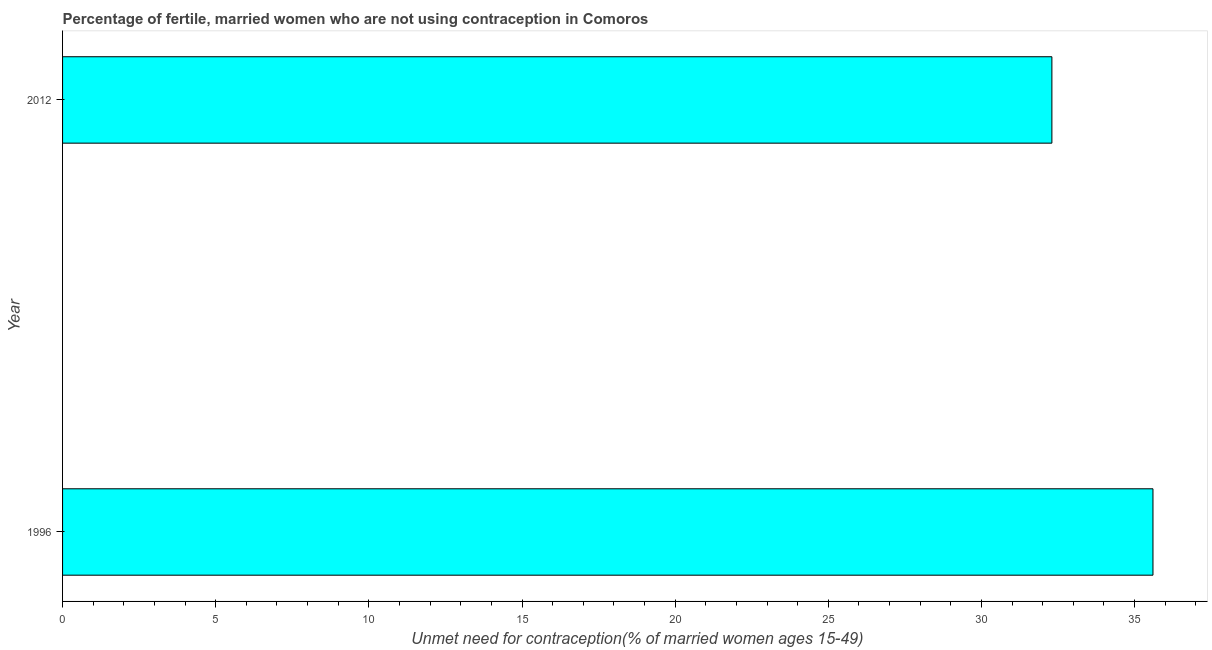Does the graph contain any zero values?
Your answer should be compact. No. What is the title of the graph?
Your answer should be compact. Percentage of fertile, married women who are not using contraception in Comoros. What is the label or title of the X-axis?
Your answer should be compact.  Unmet need for contraception(% of married women ages 15-49). What is the number of married women who are not using contraception in 1996?
Provide a succinct answer. 35.6. Across all years, what is the maximum number of married women who are not using contraception?
Give a very brief answer. 35.6. Across all years, what is the minimum number of married women who are not using contraception?
Offer a very short reply. 32.3. In which year was the number of married women who are not using contraception maximum?
Ensure brevity in your answer.  1996. In which year was the number of married women who are not using contraception minimum?
Offer a very short reply. 2012. What is the sum of the number of married women who are not using contraception?
Your answer should be very brief. 67.9. What is the difference between the number of married women who are not using contraception in 1996 and 2012?
Your response must be concise. 3.3. What is the average number of married women who are not using contraception per year?
Your answer should be compact. 33.95. What is the median number of married women who are not using contraception?
Your response must be concise. 33.95. In how many years, is the number of married women who are not using contraception greater than 25 %?
Make the answer very short. 2. Do a majority of the years between 1996 and 2012 (inclusive) have number of married women who are not using contraception greater than 1 %?
Ensure brevity in your answer.  Yes. What is the ratio of the number of married women who are not using contraception in 1996 to that in 2012?
Make the answer very short. 1.1. Is the number of married women who are not using contraception in 1996 less than that in 2012?
Offer a terse response. No. In how many years, is the number of married women who are not using contraception greater than the average number of married women who are not using contraception taken over all years?
Give a very brief answer. 1. How many bars are there?
Ensure brevity in your answer.  2. What is the difference between two consecutive major ticks on the X-axis?
Offer a very short reply. 5. What is the  Unmet need for contraception(% of married women ages 15-49) of 1996?
Give a very brief answer. 35.6. What is the  Unmet need for contraception(% of married women ages 15-49) in 2012?
Provide a short and direct response. 32.3. What is the ratio of the  Unmet need for contraception(% of married women ages 15-49) in 1996 to that in 2012?
Provide a short and direct response. 1.1. 